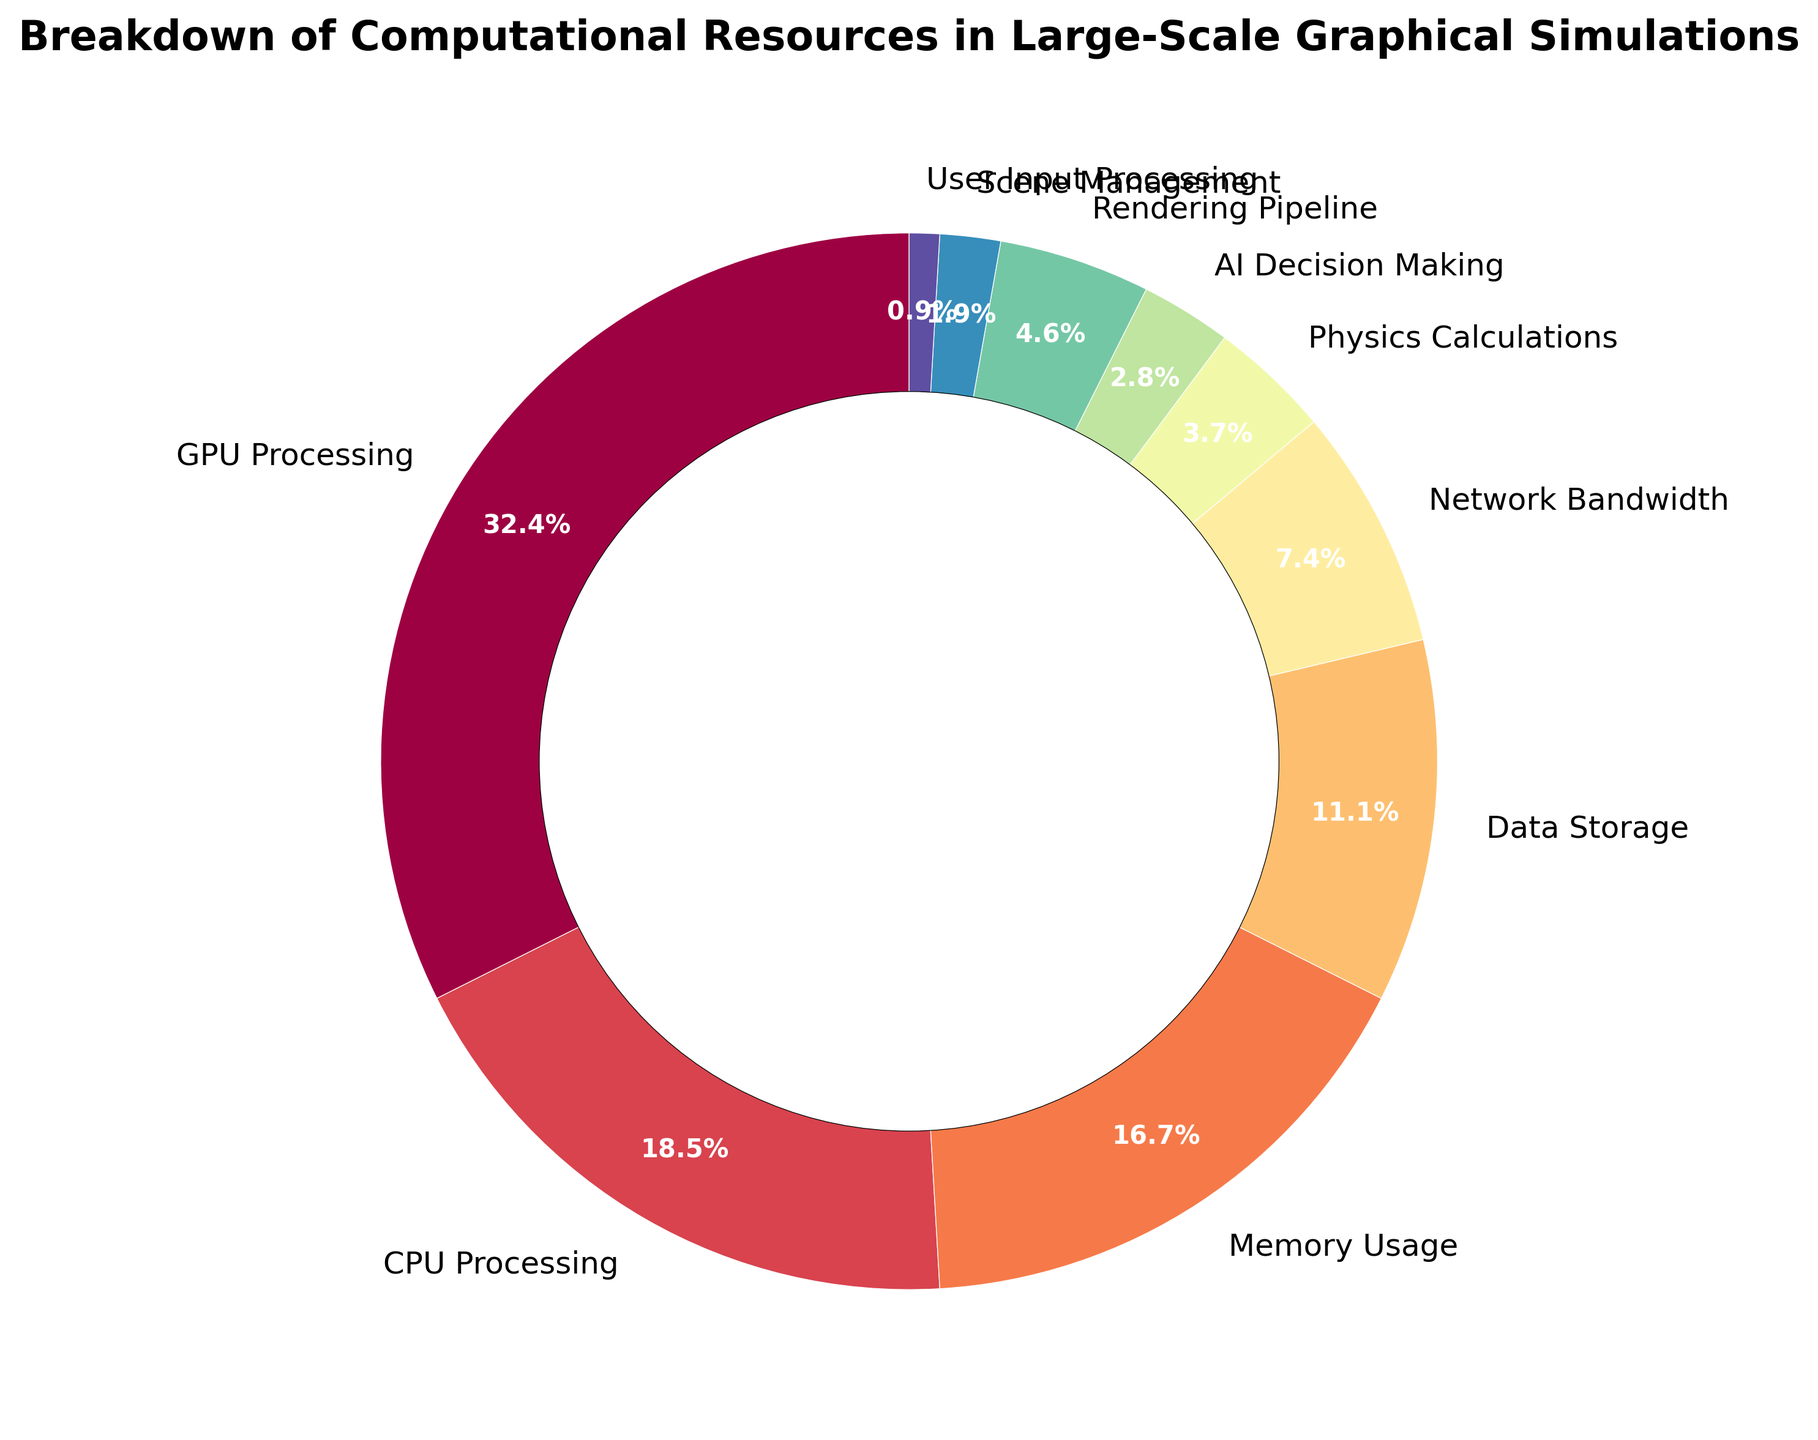What is the percentage of computational resources spent on GPU Processing? The figure shows a pie chart with segments labeled by computational resources and their respective percentages. Find the segment labeled "GPU Processing" and note its percentage.
Answer: 35% Which computational resource utilizes the least amount of percentage? Look for the smallest segment in the pie chart and identify its label.
Answer: User Input Processing How much more percentage is spent on CPU Processing compared to Memory Usage? Find the percentages for "CPU Processing" and "Memory Usage" from the chart. Subtract the percentage of Memory Usage from the CPU Processing percentage.
Answer: 2% What is the total percentage of computational resources used by AI Decision Making, Physics Calculations, and Rendering Pipeline combined? Add the percentages of "AI Decision Making," "Physics Calculations," and "Rendering Pipeline" together.
Answer: 12% Compare the percentages of Data Storage and Network Bandwidth. Which one is higher, and by how much? Locate the segments for "Data Storage" and "Network Bandwidth" and note their percentages. Subtract the smaller percentage (Network Bandwidth) from the larger percentage (Data Storage).
Answer: Data Storage is higher by 4% What is the combined percentage of resources utilized for Scene Management and User Input Processing? Add the percentages of "Scene Management" and "User Input Processing" together.
Answer: 3% Is the percentage of Memory Usage greater than the combined percentage of AI Decision Making and Scene Management? Compare the percentage of "Memory Usage" with the sum of "AI Decision Making" and "Scene Management." Note the percentage of each, then perform the sum and comparison.
Answer: Yes How much more percentage is spent on GPU Processing compared to the total percentage spent on Physics Calculations and AI Decision Making? Note the percentage for "GPU Processing" and the total of both "Physics Calculations" and "AI Decision Making" percentages. Subtract the total from GPU Processing percentage.
Answer: 28% Which resource uses the third highest percentage of computational resources? Observe the segments and identify which resource has the third largest percentage.
Answer: Memory Usage Compare the total percentage of resources used by Data Storage and Network Bandwidth to the total percentage used by CPU Processing and Memory Usage. Which pair uses more resources, and by how much? First, find the sum of percentages for "Data Storage" and "Network Bandwidth." Then, find the sum for "CPU Processing" and "Memory Usage." Compare the two sums and subtract the smaller from the larger to find the difference.
Answer: CPU Processing and Memory Usage by 18% 